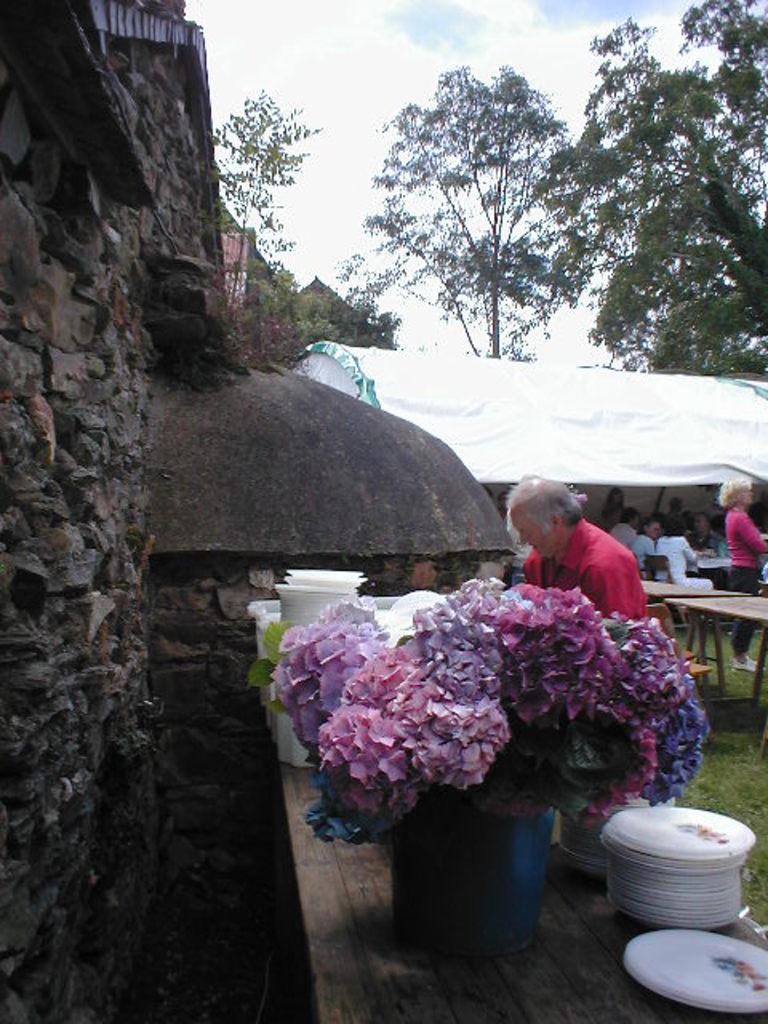Please provide a concise description of this image. There is brick wall in the left and there is a table which consists of plates and a flower vase on it and there are group of people and trees in the background. 